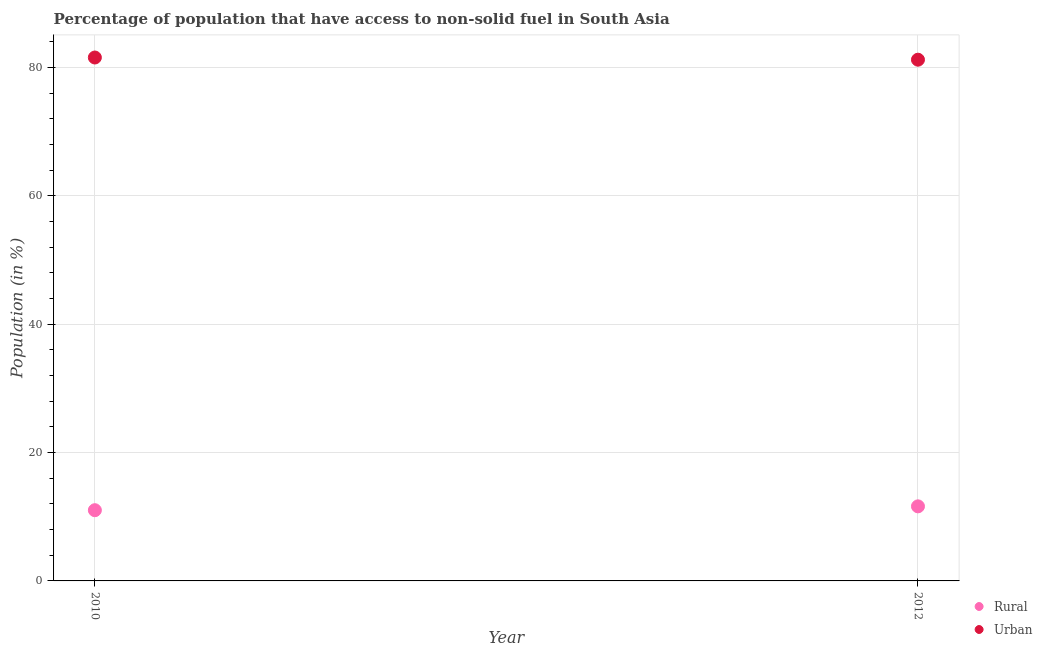How many different coloured dotlines are there?
Make the answer very short. 2. Is the number of dotlines equal to the number of legend labels?
Offer a very short reply. Yes. What is the rural population in 2010?
Your answer should be very brief. 11.02. Across all years, what is the maximum rural population?
Keep it short and to the point. 11.62. Across all years, what is the minimum rural population?
Make the answer very short. 11.02. In which year was the urban population minimum?
Offer a very short reply. 2012. What is the total urban population in the graph?
Make the answer very short. 162.78. What is the difference between the rural population in 2010 and that in 2012?
Your answer should be compact. -0.6. What is the difference between the rural population in 2010 and the urban population in 2012?
Offer a very short reply. -70.2. What is the average urban population per year?
Make the answer very short. 81.39. In the year 2012, what is the difference between the rural population and urban population?
Ensure brevity in your answer.  -69.6. What is the ratio of the rural population in 2010 to that in 2012?
Your answer should be compact. 0.95. Is the urban population in 2010 less than that in 2012?
Ensure brevity in your answer.  No. Does the rural population monotonically increase over the years?
Keep it short and to the point. Yes. What is the difference between two consecutive major ticks on the Y-axis?
Your answer should be compact. 20. Does the graph contain any zero values?
Keep it short and to the point. No. Does the graph contain grids?
Offer a terse response. Yes. How many legend labels are there?
Your answer should be very brief. 2. What is the title of the graph?
Provide a short and direct response. Percentage of population that have access to non-solid fuel in South Asia. What is the label or title of the Y-axis?
Offer a very short reply. Population (in %). What is the Population (in %) in Rural in 2010?
Your answer should be very brief. 11.02. What is the Population (in %) of Urban in 2010?
Give a very brief answer. 81.56. What is the Population (in %) of Rural in 2012?
Your answer should be very brief. 11.62. What is the Population (in %) in Urban in 2012?
Offer a terse response. 81.22. Across all years, what is the maximum Population (in %) of Rural?
Offer a terse response. 11.62. Across all years, what is the maximum Population (in %) of Urban?
Provide a short and direct response. 81.56. Across all years, what is the minimum Population (in %) in Rural?
Give a very brief answer. 11.02. Across all years, what is the minimum Population (in %) in Urban?
Provide a short and direct response. 81.22. What is the total Population (in %) in Rural in the graph?
Give a very brief answer. 22.64. What is the total Population (in %) of Urban in the graph?
Offer a terse response. 162.78. What is the difference between the Population (in %) in Rural in 2010 and that in 2012?
Keep it short and to the point. -0.6. What is the difference between the Population (in %) of Urban in 2010 and that in 2012?
Offer a very short reply. 0.34. What is the difference between the Population (in %) of Rural in 2010 and the Population (in %) of Urban in 2012?
Give a very brief answer. -70.2. What is the average Population (in %) of Rural per year?
Your answer should be very brief. 11.32. What is the average Population (in %) of Urban per year?
Make the answer very short. 81.39. In the year 2010, what is the difference between the Population (in %) in Rural and Population (in %) in Urban?
Make the answer very short. -70.54. In the year 2012, what is the difference between the Population (in %) of Rural and Population (in %) of Urban?
Offer a terse response. -69.6. What is the ratio of the Population (in %) in Rural in 2010 to that in 2012?
Provide a succinct answer. 0.95. What is the ratio of the Population (in %) in Urban in 2010 to that in 2012?
Offer a very short reply. 1. What is the difference between the highest and the second highest Population (in %) in Rural?
Make the answer very short. 0.6. What is the difference between the highest and the second highest Population (in %) of Urban?
Your answer should be compact. 0.34. What is the difference between the highest and the lowest Population (in %) of Rural?
Provide a short and direct response. 0.6. What is the difference between the highest and the lowest Population (in %) of Urban?
Provide a short and direct response. 0.34. 